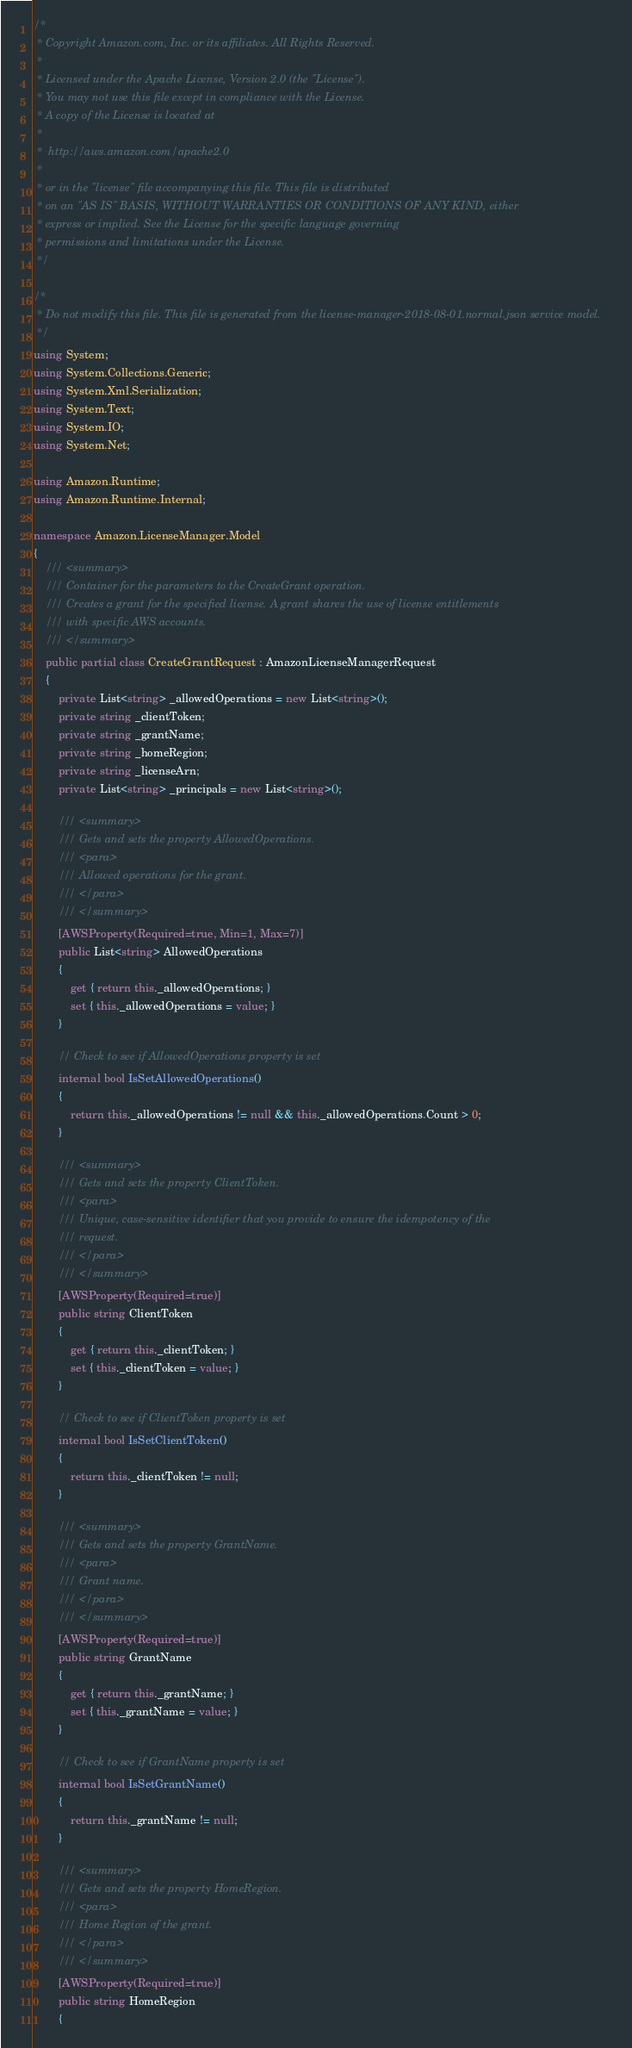Convert code to text. <code><loc_0><loc_0><loc_500><loc_500><_C#_>/*
 * Copyright Amazon.com, Inc. or its affiliates. All Rights Reserved.
 * 
 * Licensed under the Apache License, Version 2.0 (the "License").
 * You may not use this file except in compliance with the License.
 * A copy of the License is located at
 * 
 *  http://aws.amazon.com/apache2.0
 * 
 * or in the "license" file accompanying this file. This file is distributed
 * on an "AS IS" BASIS, WITHOUT WARRANTIES OR CONDITIONS OF ANY KIND, either
 * express or implied. See the License for the specific language governing
 * permissions and limitations under the License.
 */

/*
 * Do not modify this file. This file is generated from the license-manager-2018-08-01.normal.json service model.
 */
using System;
using System.Collections.Generic;
using System.Xml.Serialization;
using System.Text;
using System.IO;
using System.Net;

using Amazon.Runtime;
using Amazon.Runtime.Internal;

namespace Amazon.LicenseManager.Model
{
    /// <summary>
    /// Container for the parameters to the CreateGrant operation.
    /// Creates a grant for the specified license. A grant shares the use of license entitlements
    /// with specific AWS accounts.
    /// </summary>
    public partial class CreateGrantRequest : AmazonLicenseManagerRequest
    {
        private List<string> _allowedOperations = new List<string>();
        private string _clientToken;
        private string _grantName;
        private string _homeRegion;
        private string _licenseArn;
        private List<string> _principals = new List<string>();

        /// <summary>
        /// Gets and sets the property AllowedOperations. 
        /// <para>
        /// Allowed operations for the grant.
        /// </para>
        /// </summary>
        [AWSProperty(Required=true, Min=1, Max=7)]
        public List<string> AllowedOperations
        {
            get { return this._allowedOperations; }
            set { this._allowedOperations = value; }
        }

        // Check to see if AllowedOperations property is set
        internal bool IsSetAllowedOperations()
        {
            return this._allowedOperations != null && this._allowedOperations.Count > 0; 
        }

        /// <summary>
        /// Gets and sets the property ClientToken. 
        /// <para>
        /// Unique, case-sensitive identifier that you provide to ensure the idempotency of the
        /// request.
        /// </para>
        /// </summary>
        [AWSProperty(Required=true)]
        public string ClientToken
        {
            get { return this._clientToken; }
            set { this._clientToken = value; }
        }

        // Check to see if ClientToken property is set
        internal bool IsSetClientToken()
        {
            return this._clientToken != null;
        }

        /// <summary>
        /// Gets and sets the property GrantName. 
        /// <para>
        /// Grant name.
        /// </para>
        /// </summary>
        [AWSProperty(Required=true)]
        public string GrantName
        {
            get { return this._grantName; }
            set { this._grantName = value; }
        }

        // Check to see if GrantName property is set
        internal bool IsSetGrantName()
        {
            return this._grantName != null;
        }

        /// <summary>
        /// Gets and sets the property HomeRegion. 
        /// <para>
        /// Home Region of the grant.
        /// </para>
        /// </summary>
        [AWSProperty(Required=true)]
        public string HomeRegion
        {</code> 